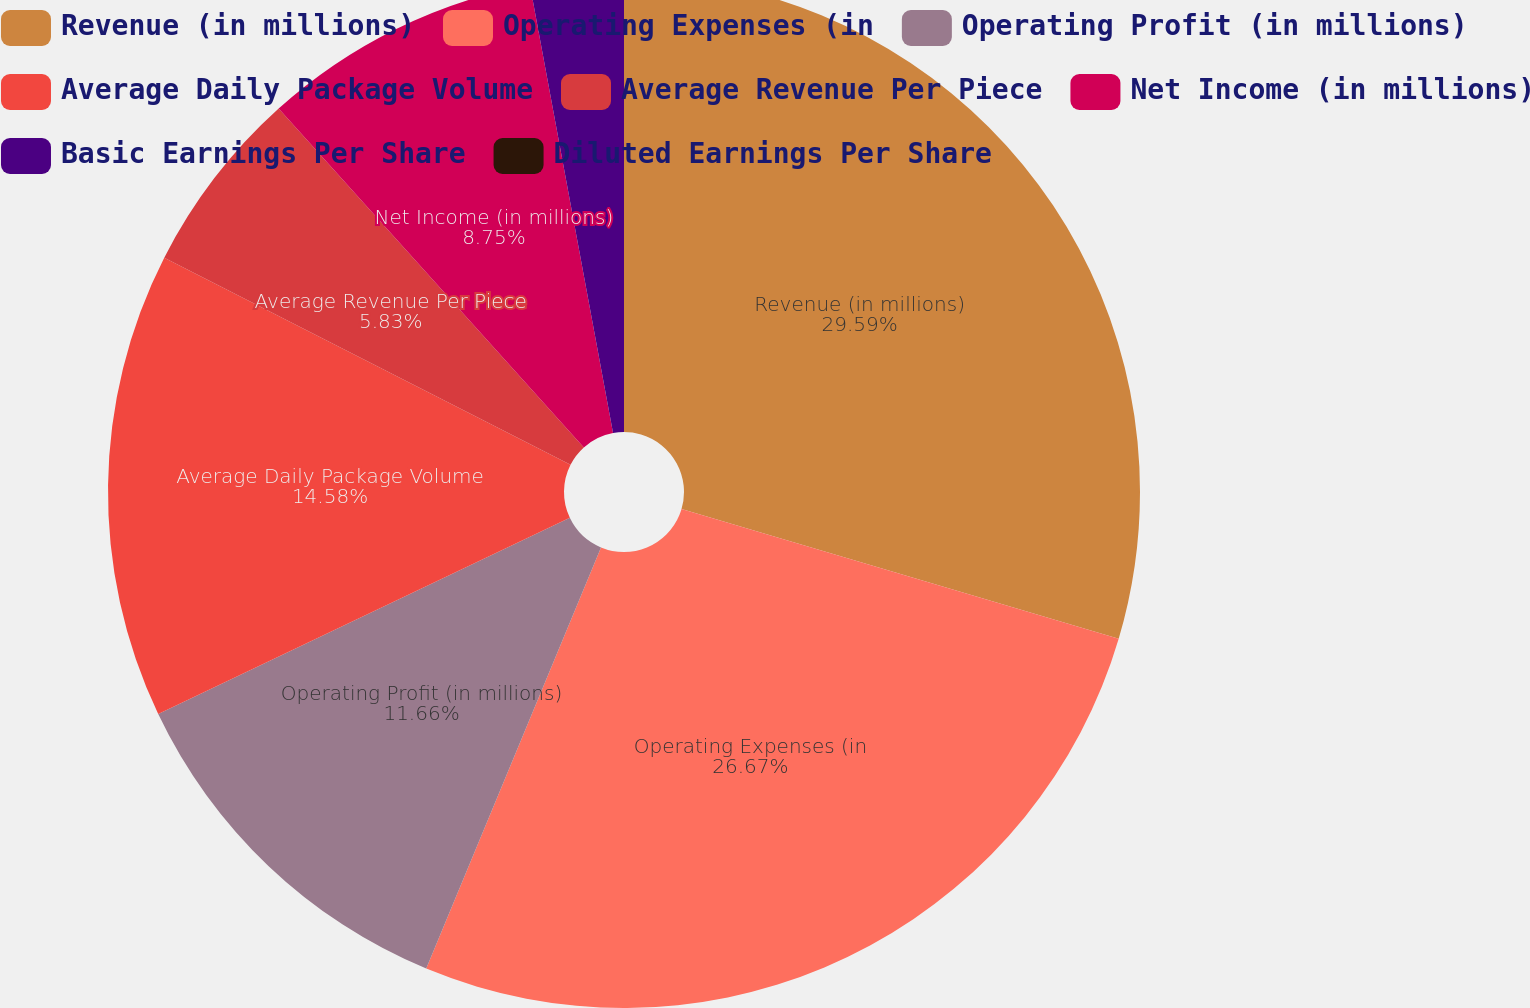<chart> <loc_0><loc_0><loc_500><loc_500><pie_chart><fcel>Revenue (in millions)<fcel>Operating Expenses (in<fcel>Operating Profit (in millions)<fcel>Average Daily Package Volume<fcel>Average Revenue Per Piece<fcel>Net Income (in millions)<fcel>Basic Earnings Per Share<fcel>Diluted Earnings Per Share<nl><fcel>29.59%<fcel>26.67%<fcel>11.66%<fcel>14.58%<fcel>5.83%<fcel>8.75%<fcel>2.92%<fcel>0.0%<nl></chart> 